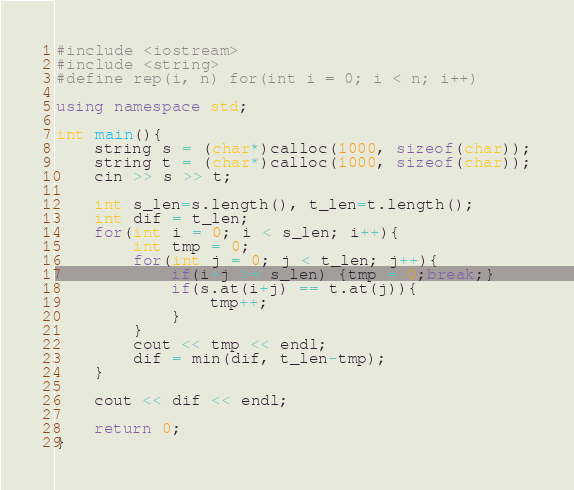Convert code to text. <code><loc_0><loc_0><loc_500><loc_500><_C++_>#include <iostream>
#include <string>
#define rep(i, n) for(int i = 0; i < n; i++)

using namespace std;

int main(){
	string s = (char*)calloc(1000, sizeof(char));
	string t = (char*)calloc(1000, sizeof(char));
	cin >> s >> t;
	
	int s_len=s.length(), t_len=t.length();
	int dif = t_len;
	for(int i = 0; i < s_len; i++){
		int tmp = 0;
		for(int j = 0; j < t_len; j++){
			if(i+j >= s_len) {tmp = 0;break;}
			if(s.at(i+j) == t.at(j)){
				tmp++;
			}
		}
		cout << tmp << endl;
		dif = min(dif, t_len-tmp);
	}
	
	cout << dif << endl;
	
	return 0;
}</code> 